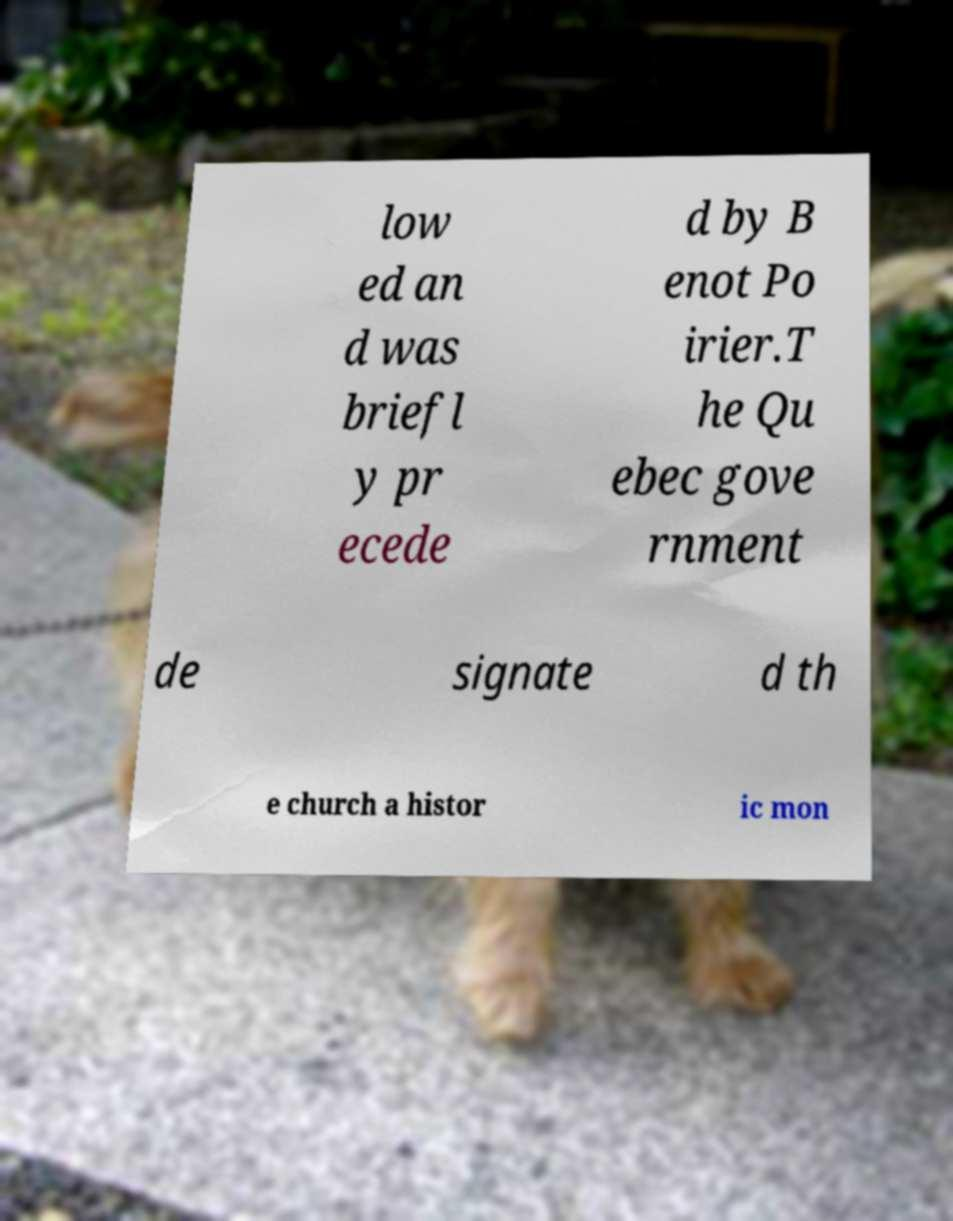There's text embedded in this image that I need extracted. Can you transcribe it verbatim? low ed an d was briefl y pr ecede d by B enot Po irier.T he Qu ebec gove rnment de signate d th e church a histor ic mon 